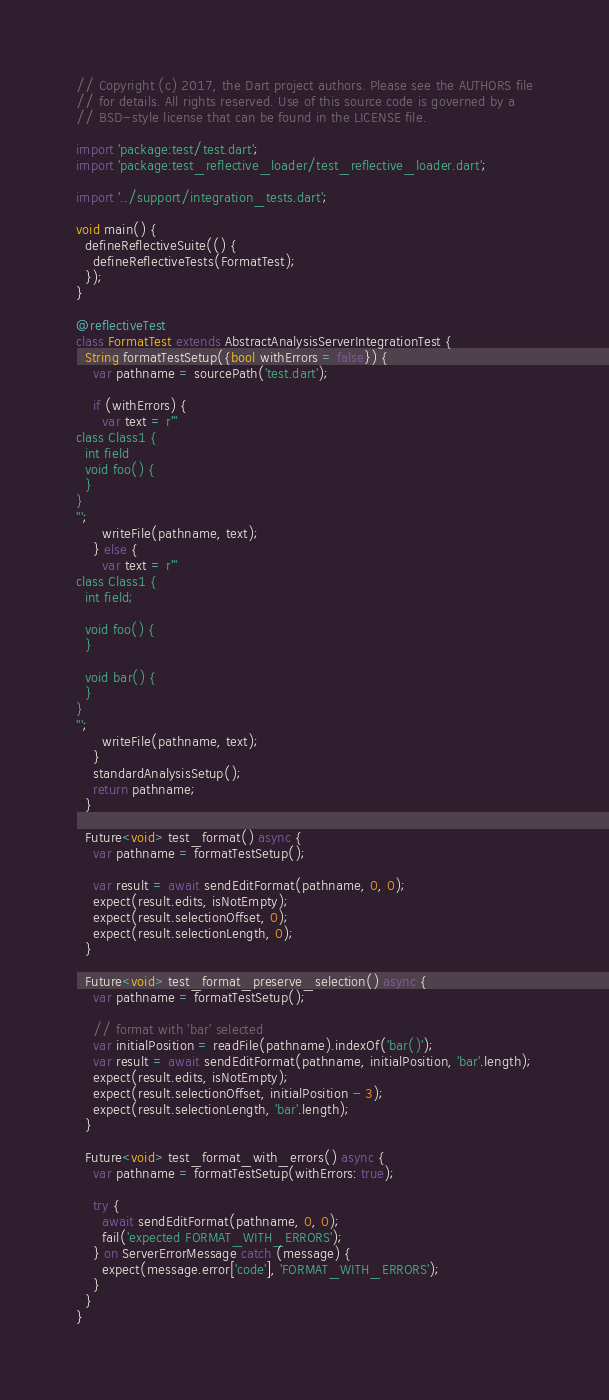Convert code to text. <code><loc_0><loc_0><loc_500><loc_500><_Dart_>// Copyright (c) 2017, the Dart project authors. Please see the AUTHORS file
// for details. All rights reserved. Use of this source code is governed by a
// BSD-style license that can be found in the LICENSE file.

import 'package:test/test.dart';
import 'package:test_reflective_loader/test_reflective_loader.dart';

import '../support/integration_tests.dart';

void main() {
  defineReflectiveSuite(() {
    defineReflectiveTests(FormatTest);
  });
}

@reflectiveTest
class FormatTest extends AbstractAnalysisServerIntegrationTest {
  String formatTestSetup({bool withErrors = false}) {
    var pathname = sourcePath('test.dart');

    if (withErrors) {
      var text = r'''
class Class1 {
  int field
  void foo() {
  }
}
''';
      writeFile(pathname, text);
    } else {
      var text = r'''
class Class1 {
  int field;

  void foo() {
  }

  void bar() {
  }
}
''';
      writeFile(pathname, text);
    }
    standardAnalysisSetup();
    return pathname;
  }

  Future<void> test_format() async {
    var pathname = formatTestSetup();

    var result = await sendEditFormat(pathname, 0, 0);
    expect(result.edits, isNotEmpty);
    expect(result.selectionOffset, 0);
    expect(result.selectionLength, 0);
  }

  Future<void> test_format_preserve_selection() async {
    var pathname = formatTestSetup();

    // format with 'bar' selected
    var initialPosition = readFile(pathname).indexOf('bar()');
    var result = await sendEditFormat(pathname, initialPosition, 'bar'.length);
    expect(result.edits, isNotEmpty);
    expect(result.selectionOffset, initialPosition - 3);
    expect(result.selectionLength, 'bar'.length);
  }

  Future<void> test_format_with_errors() async {
    var pathname = formatTestSetup(withErrors: true);

    try {
      await sendEditFormat(pathname, 0, 0);
      fail('expected FORMAT_WITH_ERRORS');
    } on ServerErrorMessage catch (message) {
      expect(message.error['code'], 'FORMAT_WITH_ERRORS');
    }
  }
}
</code> 